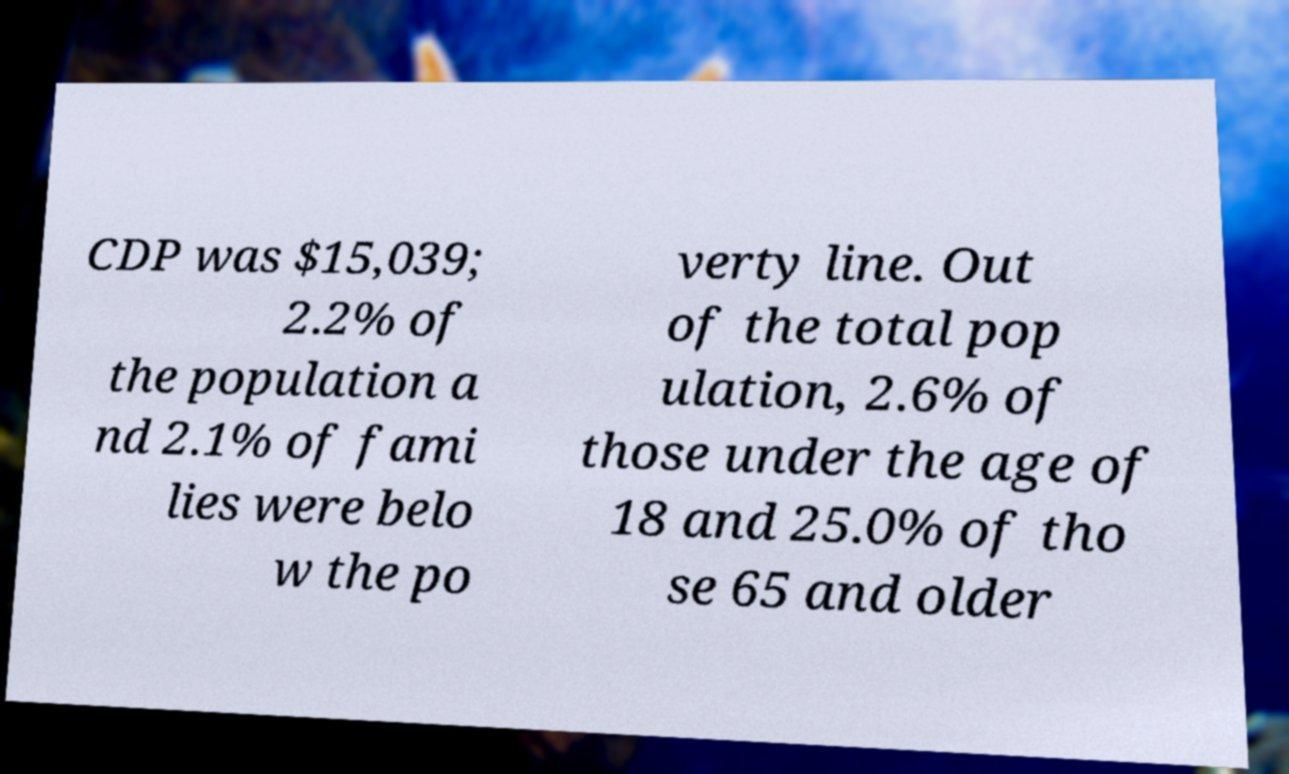Can you accurately transcribe the text from the provided image for me? CDP was $15,039; 2.2% of the population a nd 2.1% of fami lies were belo w the po verty line. Out of the total pop ulation, 2.6% of those under the age of 18 and 25.0% of tho se 65 and older 